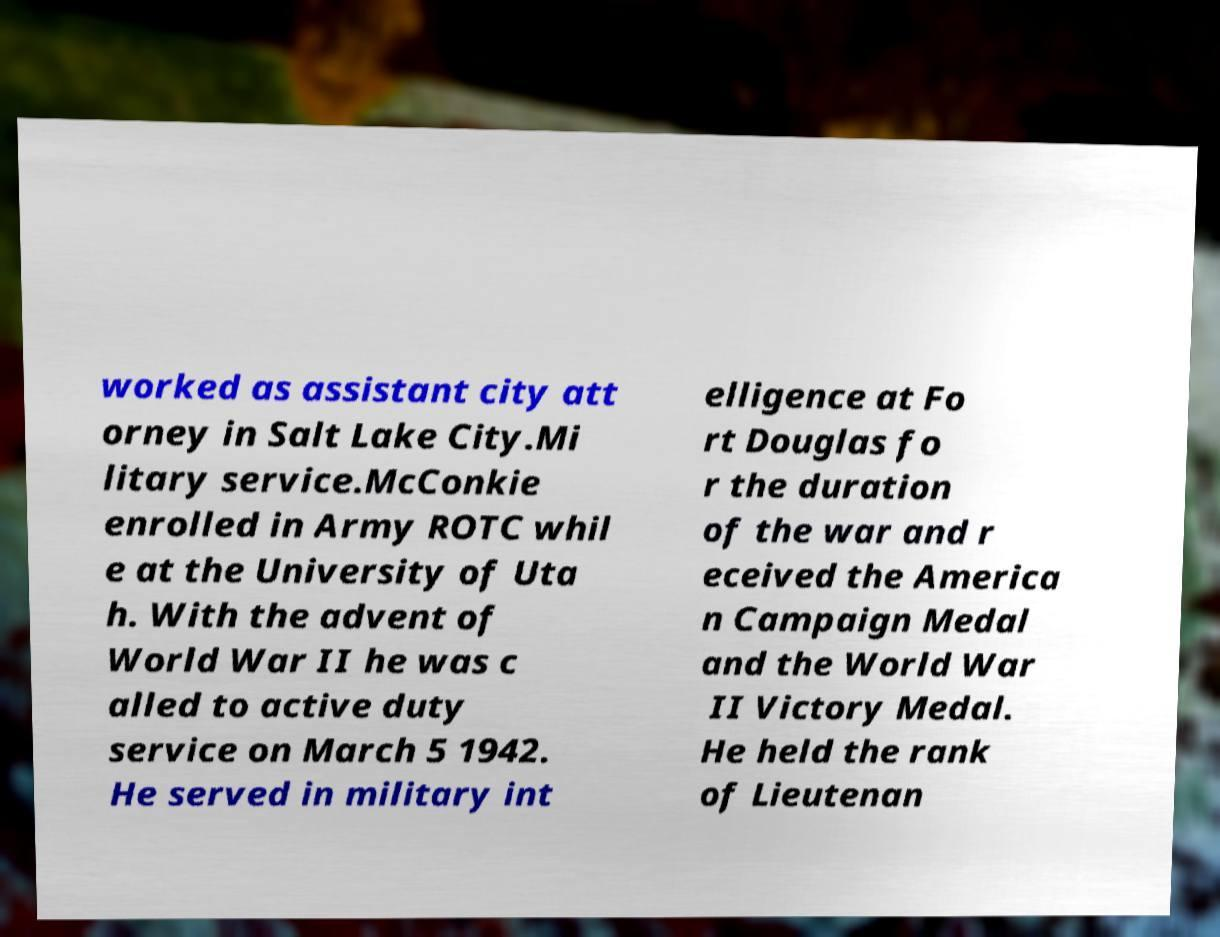Can you accurately transcribe the text from the provided image for me? worked as assistant city att orney in Salt Lake City.Mi litary service.McConkie enrolled in Army ROTC whil e at the University of Uta h. With the advent of World War II he was c alled to active duty service on March 5 1942. He served in military int elligence at Fo rt Douglas fo r the duration of the war and r eceived the America n Campaign Medal and the World War II Victory Medal. He held the rank of Lieutenan 